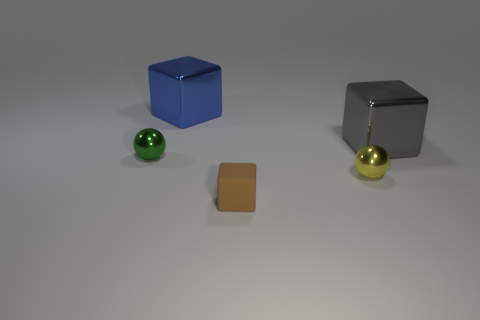Can you describe the positioning of all objects in the image? In the image, there is a large blue block positioned on the left, a small metallic cube near the center, and two small spheres - one shiny green on the far left and one shiny gold on the right - with a small brown square object in front of them. All objects are placed on a flat surface with a neutral gray background.  What could be the possible materials of these objects? The large blue block looks like it could be made of a matte plastic, the small metallic cube seems to be metal, possibly stainless steel, the green sphere appears shiny, suggesting a glass-like material, while the gold sphere might be made of a polished metal or plastic. The small brown square object could be made of cardboard or a similar paper-based material. 